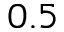<formula> <loc_0><loc_0><loc_500><loc_500>0 . 5</formula> 